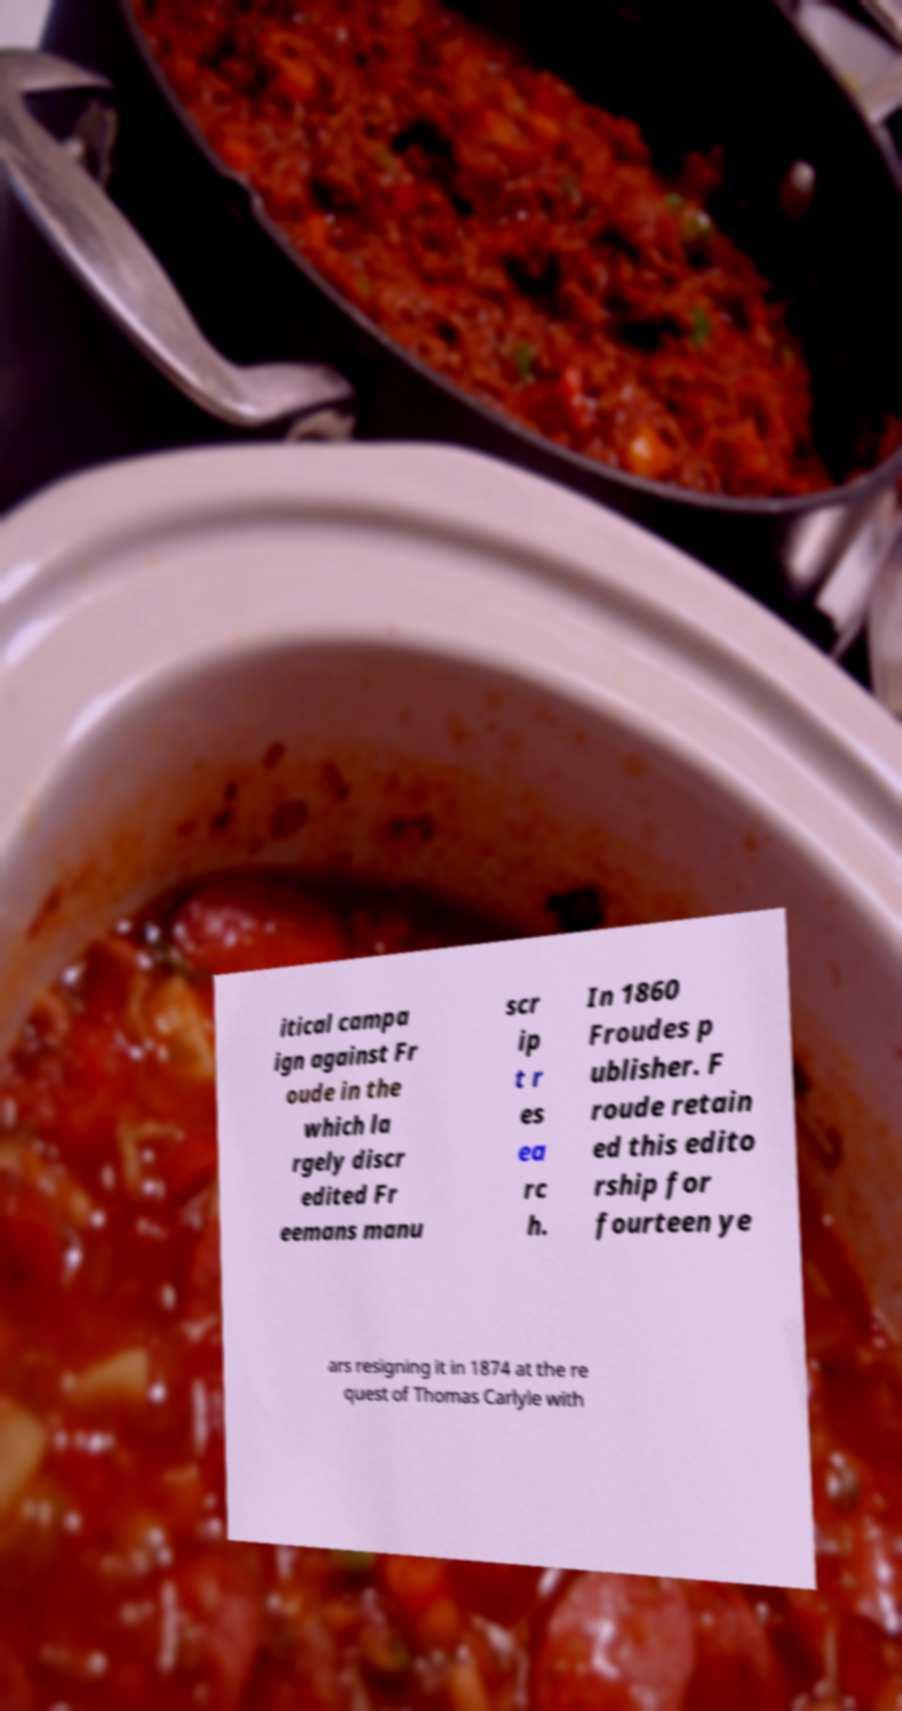Can you accurately transcribe the text from the provided image for me? itical campa ign against Fr oude in the which la rgely discr edited Fr eemans manu scr ip t r es ea rc h. In 1860 Froudes p ublisher. F roude retain ed this edito rship for fourteen ye ars resigning it in 1874 at the re quest of Thomas Carlyle with 